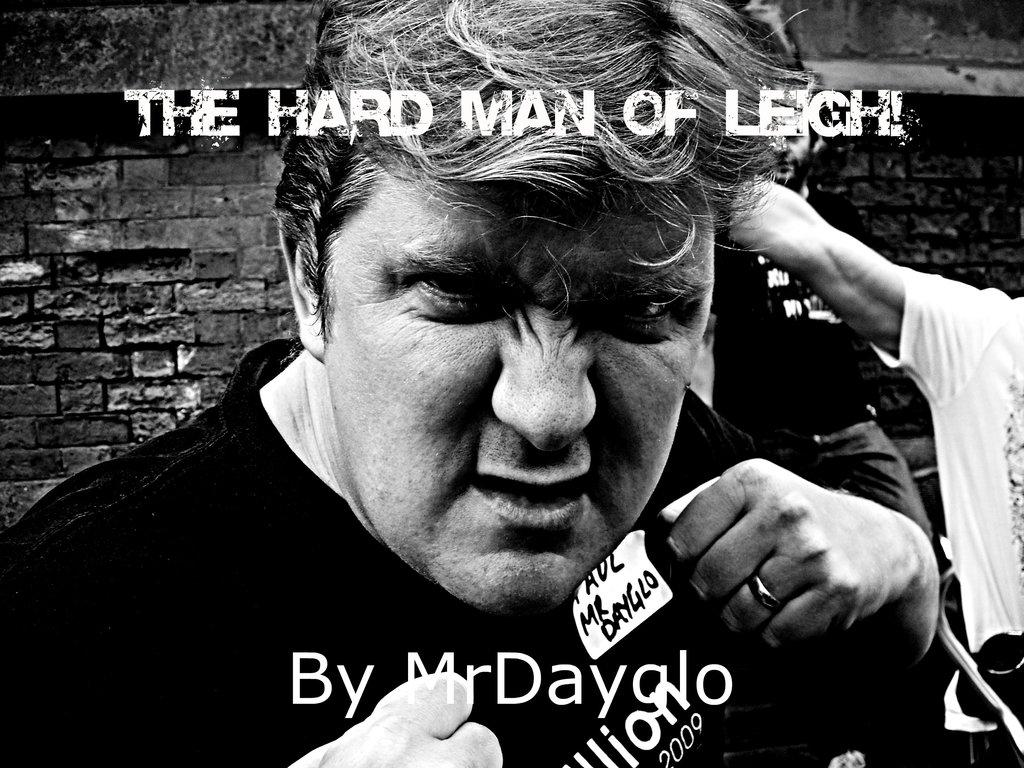Who is the main subject in the image? There is a man in the center of the image. What is the man wearing? The man is wearing a black shirt. What can be seen in the background of the image? There are people and a wall in the background of the image. What type of clam is being used as a prop in the image? There is no clam present in the image. What type of yarn is the man using to create a pattern in the image? There is no yarn or pattern-making activity depicted in the image. 